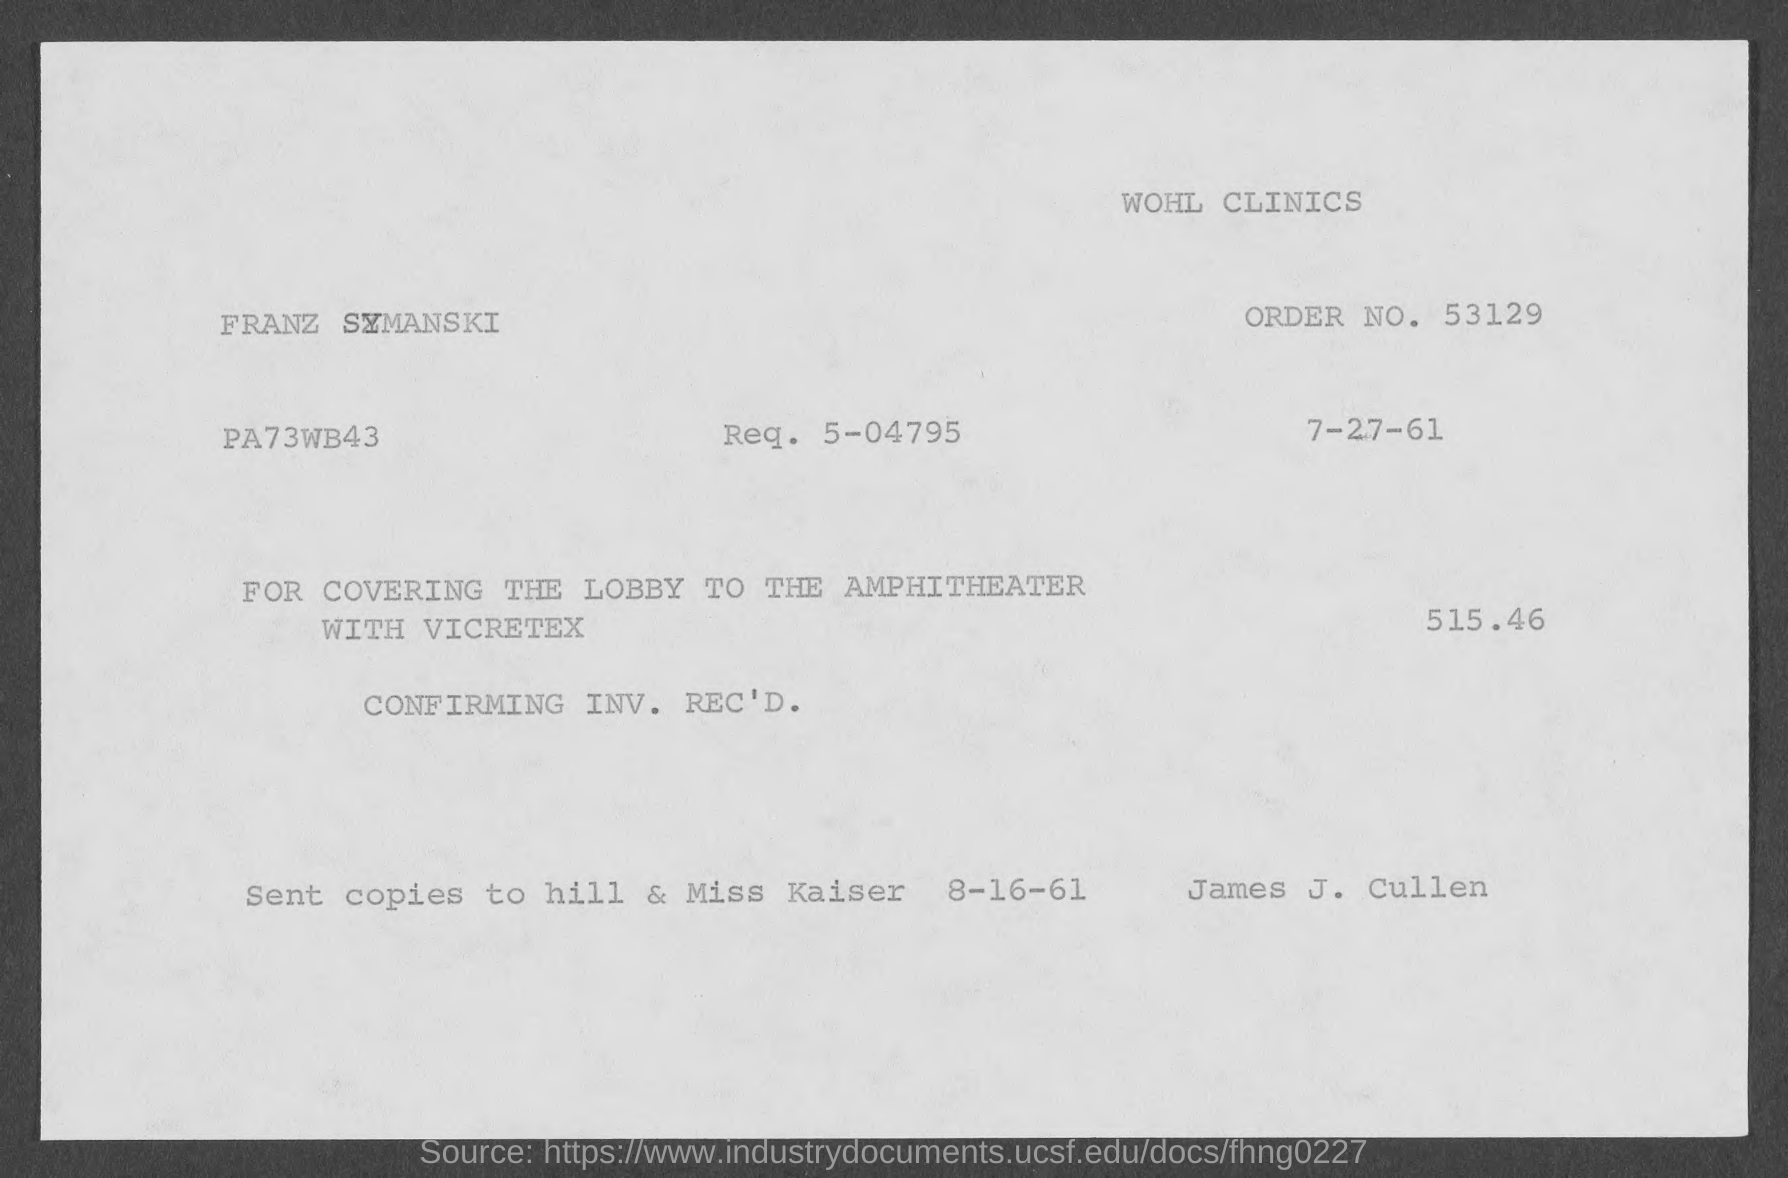Point out several critical features in this image. I have a question about an order number. Could you please provide the order number? What is the request number for 5-04795? 